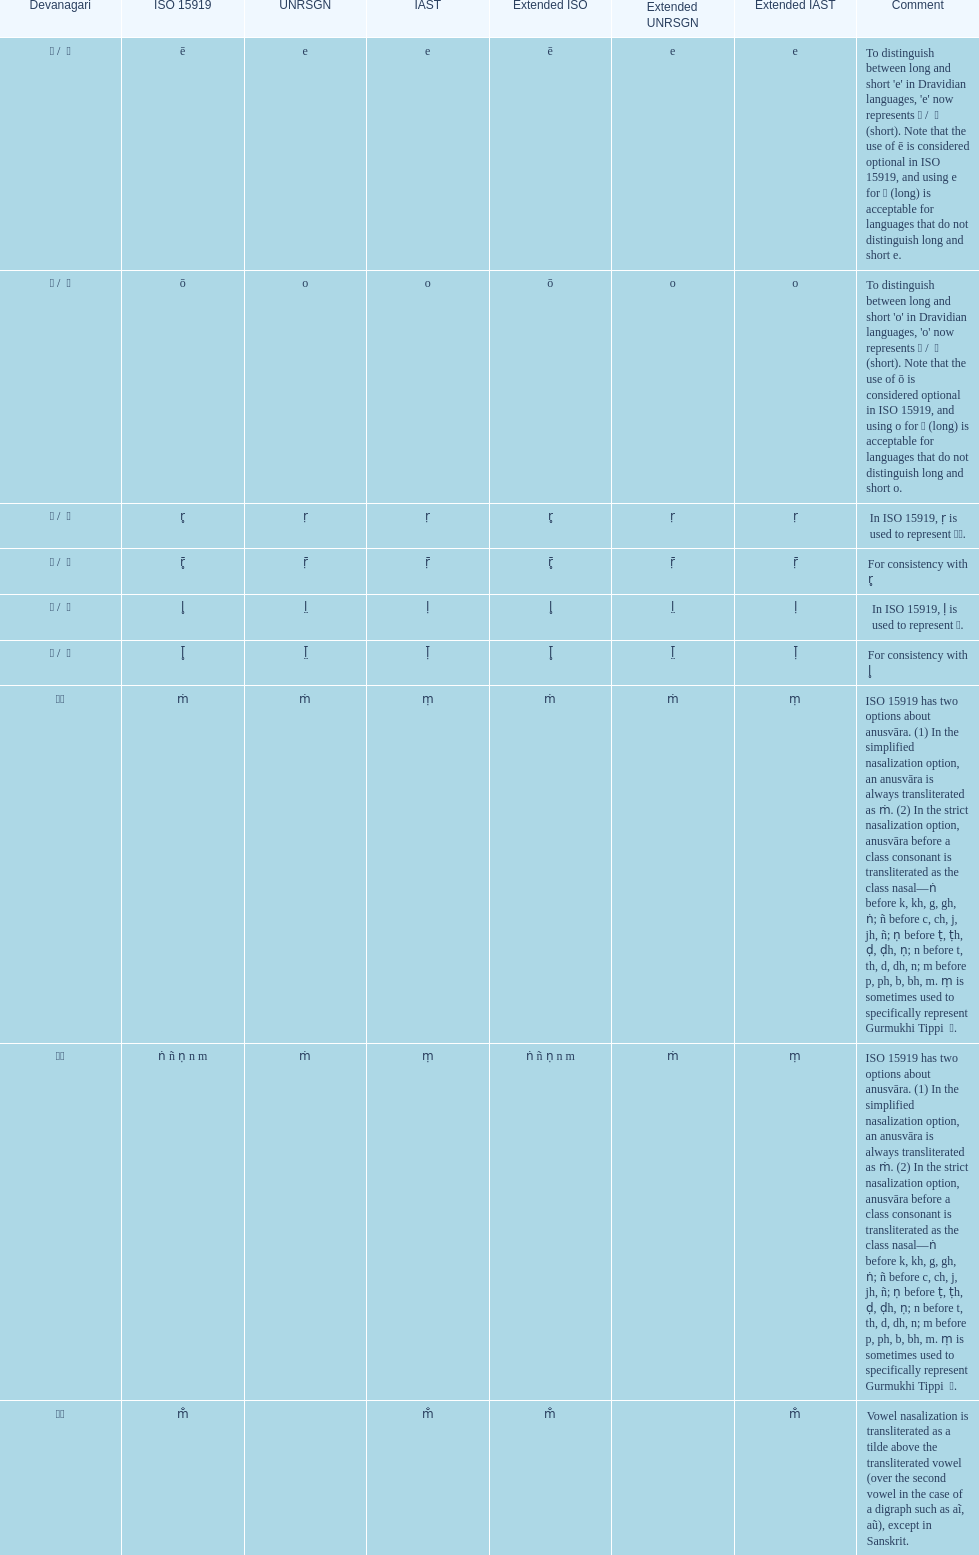Which devanagaria means the same as this iast letter: o? ओ / ो. 